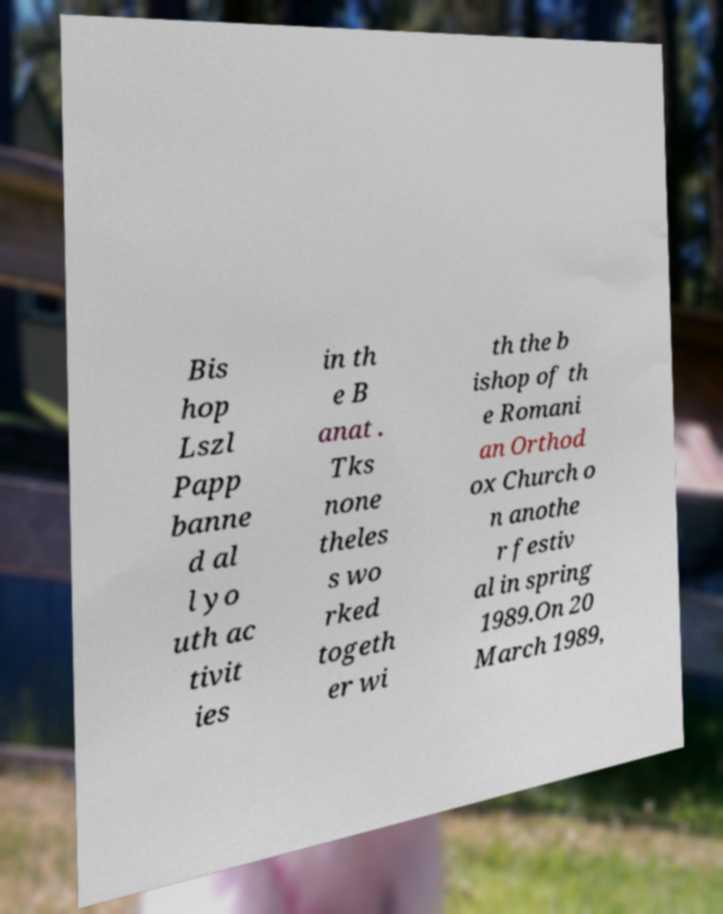Could you assist in decoding the text presented in this image and type it out clearly? Bis hop Lszl Papp banne d al l yo uth ac tivit ies in th e B anat . Tks none theles s wo rked togeth er wi th the b ishop of th e Romani an Orthod ox Church o n anothe r festiv al in spring 1989.On 20 March 1989, 